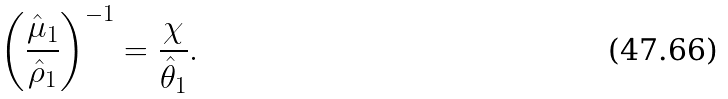<formula> <loc_0><loc_0><loc_500><loc_500>\left ( \frac { \hat { \mu } _ { 1 } } { \hat { \rho } _ { 1 } } \right ) ^ { - 1 } = \frac { \chi } { \hat { \theta } _ { 1 } } .</formula> 